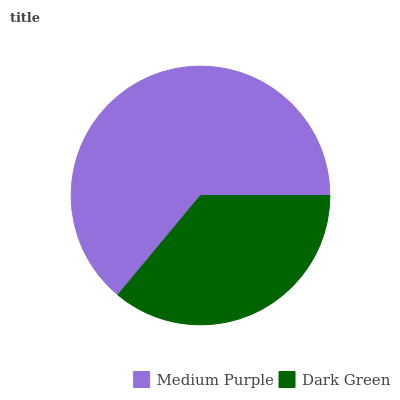Is Dark Green the minimum?
Answer yes or no. Yes. Is Medium Purple the maximum?
Answer yes or no. Yes. Is Dark Green the maximum?
Answer yes or no. No. Is Medium Purple greater than Dark Green?
Answer yes or no. Yes. Is Dark Green less than Medium Purple?
Answer yes or no. Yes. Is Dark Green greater than Medium Purple?
Answer yes or no. No. Is Medium Purple less than Dark Green?
Answer yes or no. No. Is Medium Purple the high median?
Answer yes or no. Yes. Is Dark Green the low median?
Answer yes or no. Yes. Is Dark Green the high median?
Answer yes or no. No. Is Medium Purple the low median?
Answer yes or no. No. 